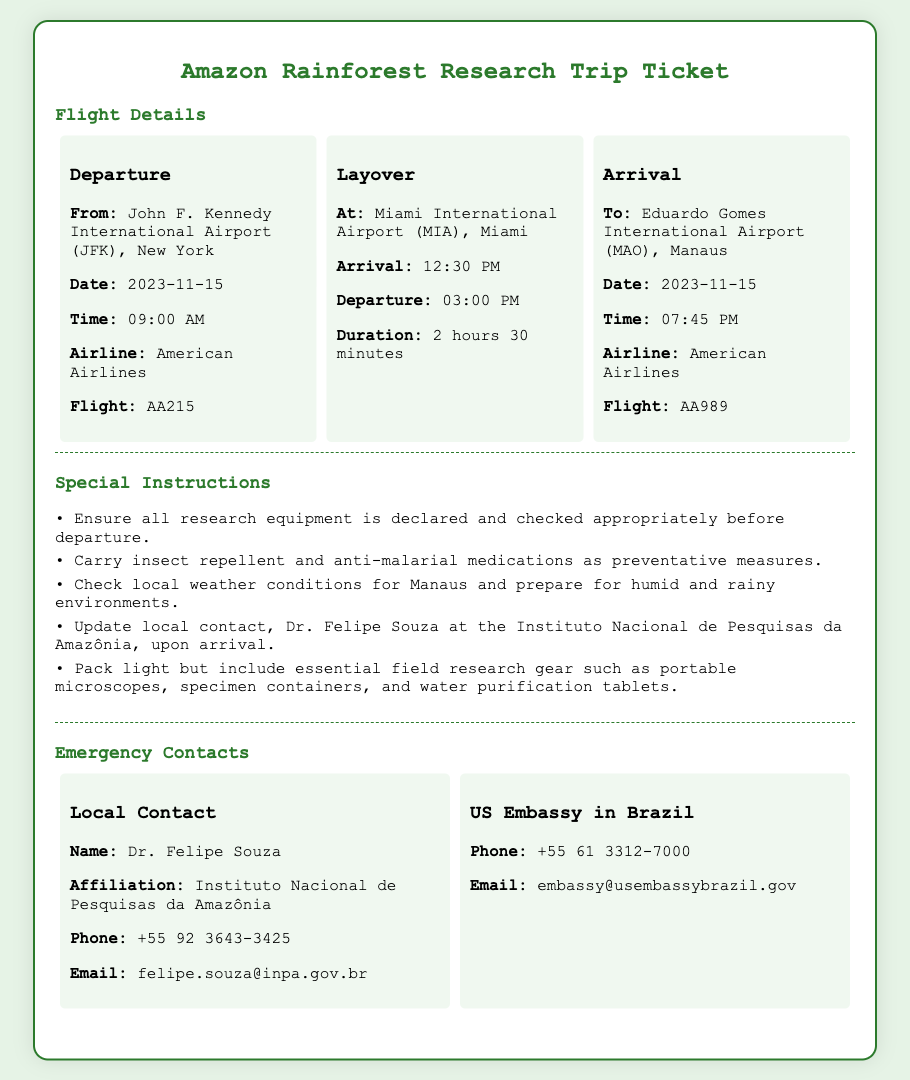What is the departure airport? The departure airport is listed in the flight details under "From."
Answer: John F. Kennedy International Airport (JFK), New York What is the layover duration? The layover duration is provided in the layover section.
Answer: 2 hours 30 minutes What flight will arrive at Manaus? The arrival flight information specifies which flight lands at Manaus.
Answer: AA989 Who is the local contact for the research trip? The local contact's name and affiliation are provided under "Local Contact."
Answer: Dr. Felipe Souza What special instruction mentions health precautions? One of the special instructions is specifically about health precautions for the trip.
Answer: Carry insect repellent and anti-malarial medications as preventative measures What is the departure date for the flight? The departure date is stated in the flight details under the "Date" section for departure.
Answer: 2023-11-15 What is the email address of the local contact? The email of the local contact is detailed in the "Local Contact" section.
Answer: felipe.souza@inpa.gov.br What airline operates the departing flight? The airline for the departure flight is specified in the flight details.
Answer: American Airlines What is recommended to pack for field research? The special instructions include recommendations on what to pack for research.
Answer: Portable microscopes, specimen containers, and water purification tablets 